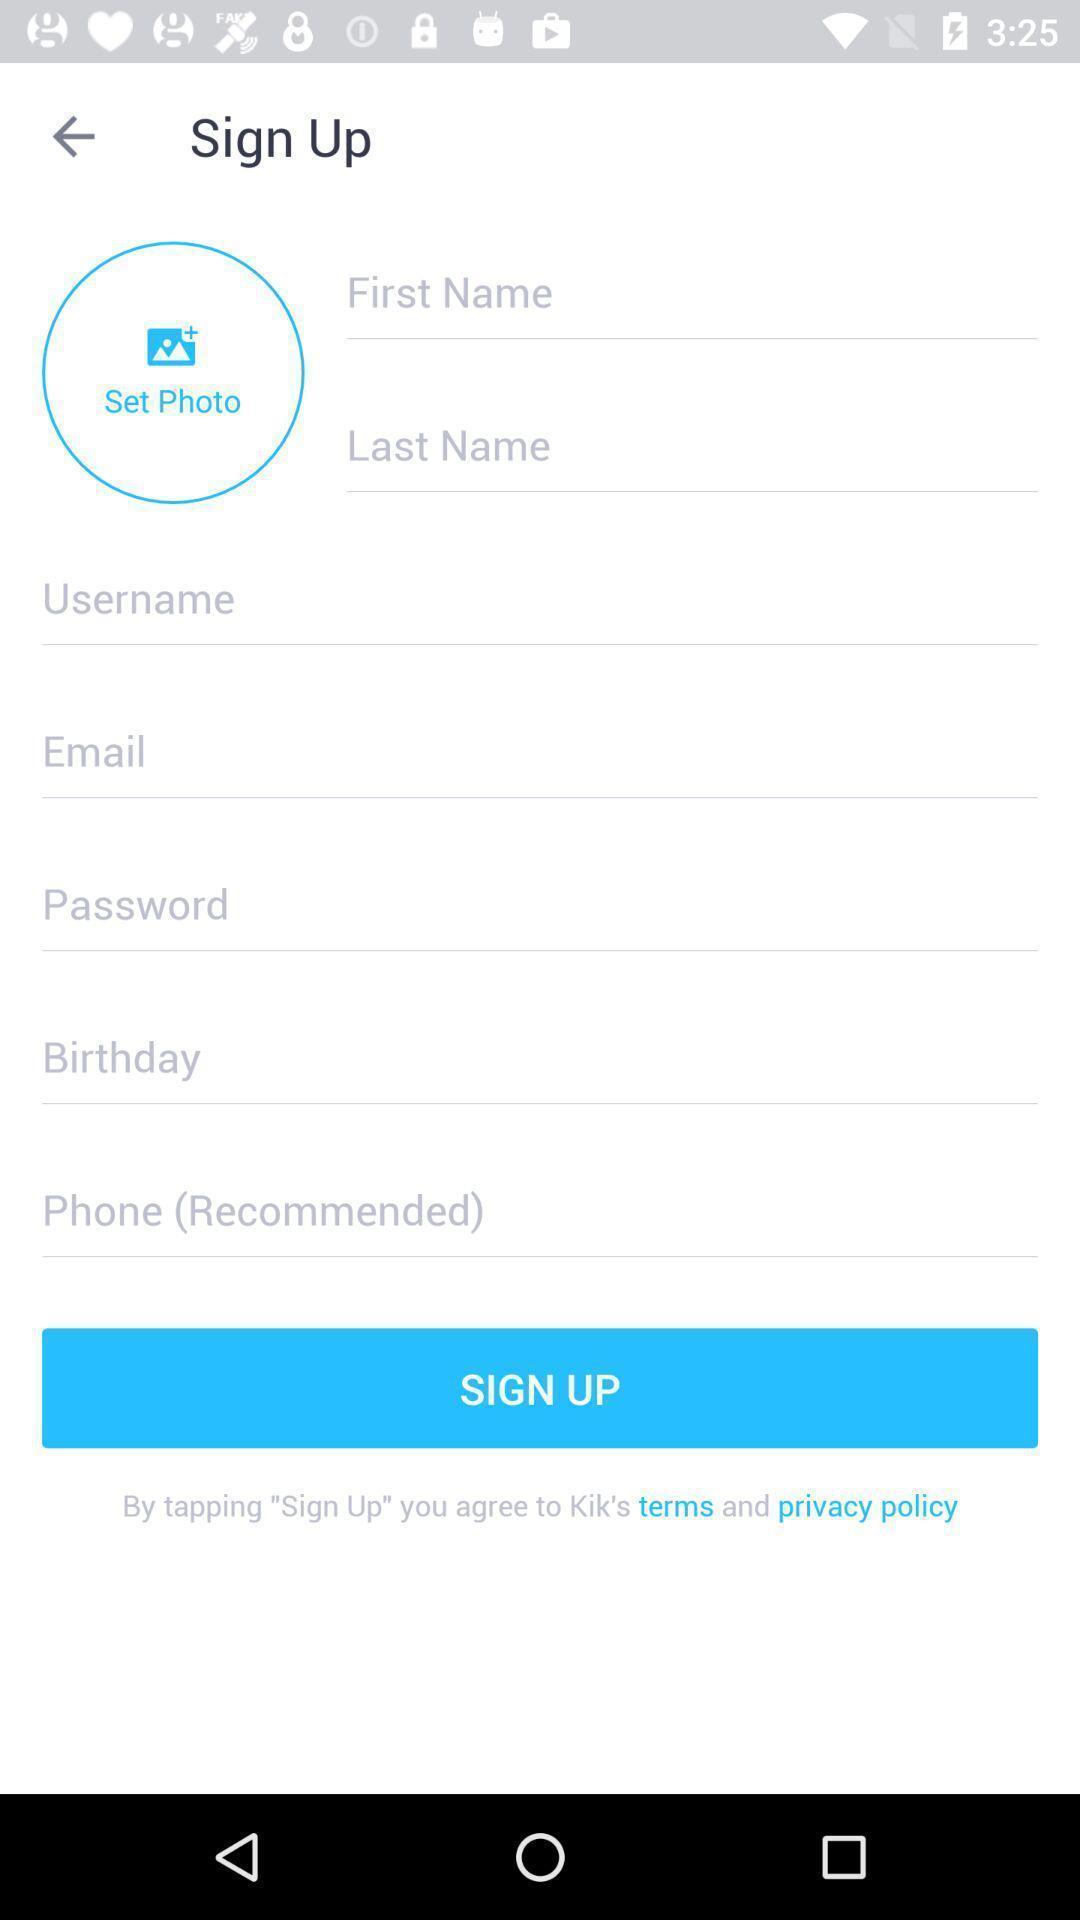Tell me what you see in this picture. Welcome page of social application. 